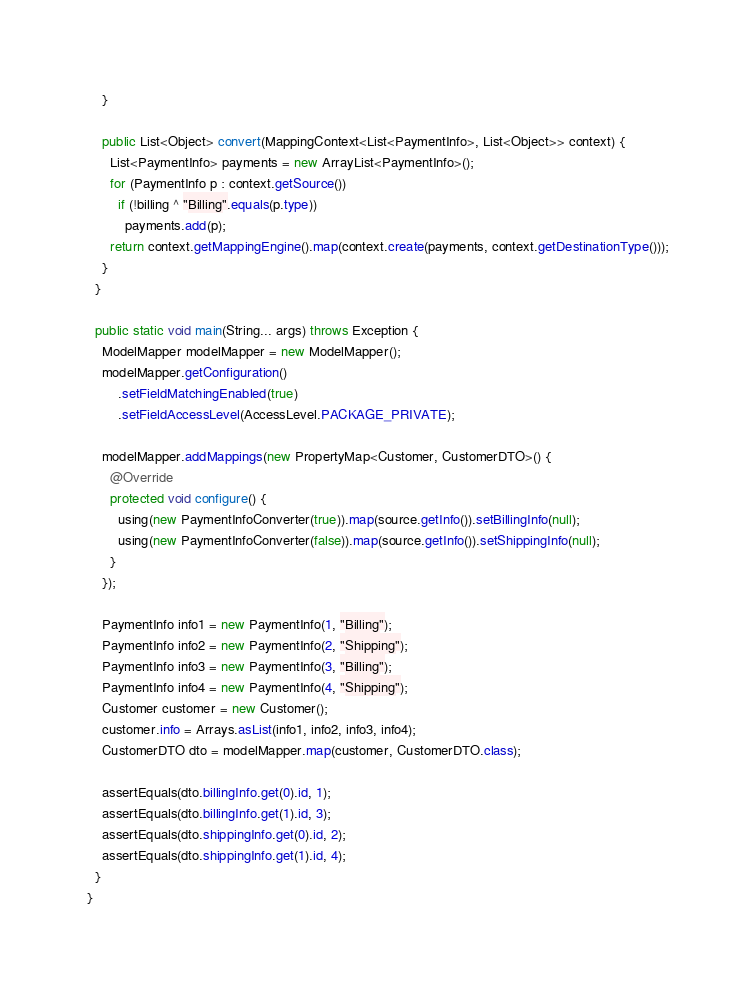<code> <loc_0><loc_0><loc_500><loc_500><_Java_>    }

    public List<Object> convert(MappingContext<List<PaymentInfo>, List<Object>> context) {
      List<PaymentInfo> payments = new ArrayList<PaymentInfo>();
      for (PaymentInfo p : context.getSource())
        if (!billing ^ "Billing".equals(p.type))
          payments.add(p);
      return context.getMappingEngine().map(context.create(payments, context.getDestinationType()));
    }
  }

  public static void main(String... args) throws Exception {
    ModelMapper modelMapper = new ModelMapper();
    modelMapper.getConfiguration()
        .setFieldMatchingEnabled(true)
        .setFieldAccessLevel(AccessLevel.PACKAGE_PRIVATE);

    modelMapper.addMappings(new PropertyMap<Customer, CustomerDTO>() {
      @Override
      protected void configure() {
        using(new PaymentInfoConverter(true)).map(source.getInfo()).setBillingInfo(null);
        using(new PaymentInfoConverter(false)).map(source.getInfo()).setShippingInfo(null);
      }
    });

    PaymentInfo info1 = new PaymentInfo(1, "Billing");
    PaymentInfo info2 = new PaymentInfo(2, "Shipping");
    PaymentInfo info3 = new PaymentInfo(3, "Billing");
    PaymentInfo info4 = new PaymentInfo(4, "Shipping");
    Customer customer = new Customer();
    customer.info = Arrays.asList(info1, info2, info3, info4);
    CustomerDTO dto = modelMapper.map(customer, CustomerDTO.class);

    assertEquals(dto.billingInfo.get(0).id, 1);
    assertEquals(dto.billingInfo.get(1).id, 3);
    assertEquals(dto.shippingInfo.get(0).id, 2);
    assertEquals(dto.shippingInfo.get(1).id, 4);
  }
}
</code> 